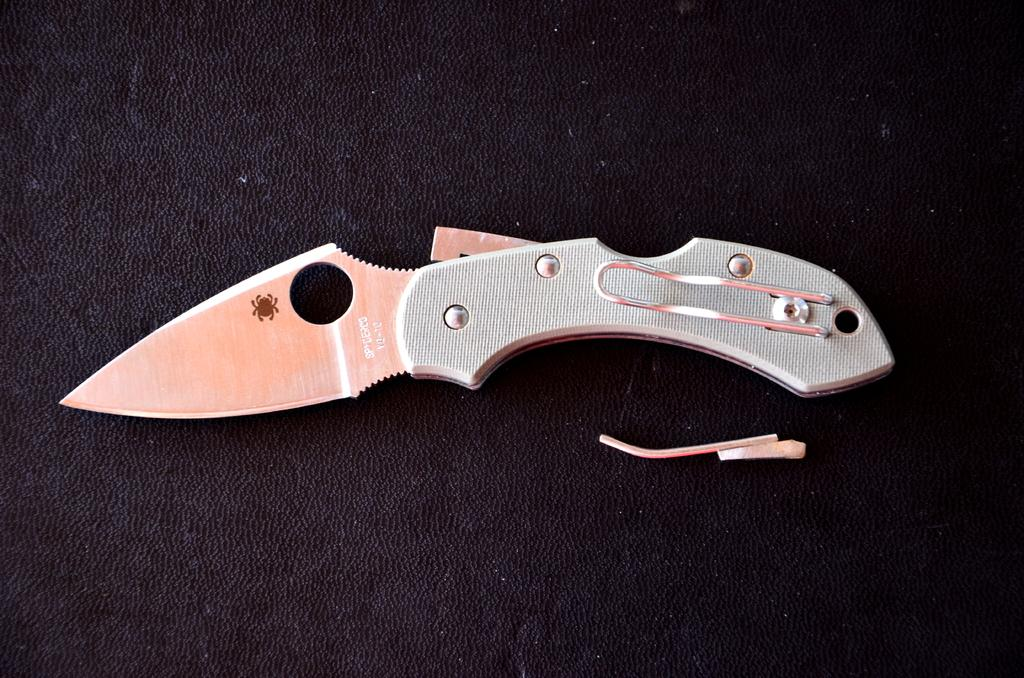What object can be seen on the table in the image? There is a knife in the image. What is the color of the knife? The knife is black in color. What type of wool can be seen being used to make the knife in the image? There is no wool present in the image, and the knife is not made of wool. 